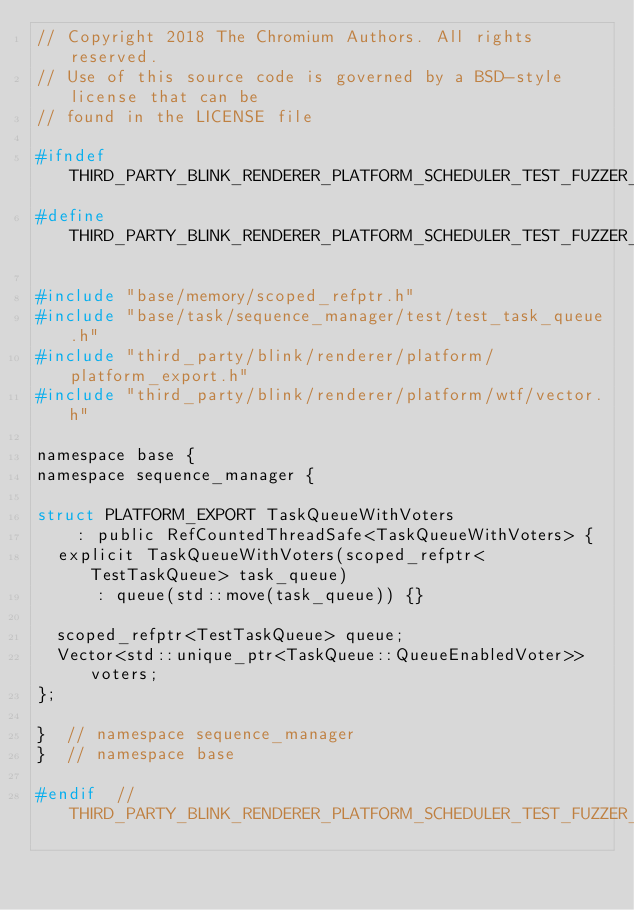Convert code to text. <code><loc_0><loc_0><loc_500><loc_500><_C_>// Copyright 2018 The Chromium Authors. All rights reserved.
// Use of this source code is governed by a BSD-style license that can be
// found in the LICENSE file

#ifndef THIRD_PARTY_BLINK_RENDERER_PLATFORM_SCHEDULER_TEST_FUZZER_TASK_QUEUE_WITH_VOTERS_H_
#define THIRD_PARTY_BLINK_RENDERER_PLATFORM_SCHEDULER_TEST_FUZZER_TASK_QUEUE_WITH_VOTERS_H_

#include "base/memory/scoped_refptr.h"
#include "base/task/sequence_manager/test/test_task_queue.h"
#include "third_party/blink/renderer/platform/platform_export.h"
#include "third_party/blink/renderer/platform/wtf/vector.h"

namespace base {
namespace sequence_manager {

struct PLATFORM_EXPORT TaskQueueWithVoters
    : public RefCountedThreadSafe<TaskQueueWithVoters> {
  explicit TaskQueueWithVoters(scoped_refptr<TestTaskQueue> task_queue)
      : queue(std::move(task_queue)) {}

  scoped_refptr<TestTaskQueue> queue;
  Vector<std::unique_ptr<TaskQueue::QueueEnabledVoter>> voters;
};

}  // namespace sequence_manager
}  // namespace base

#endif  // THIRD_PARTY_BLINK_RENDERER_PLATFORM_SCHEDULER_TEST_FUZZER_TASK_QUEUE_WITH_VOTERS_H_
</code> 